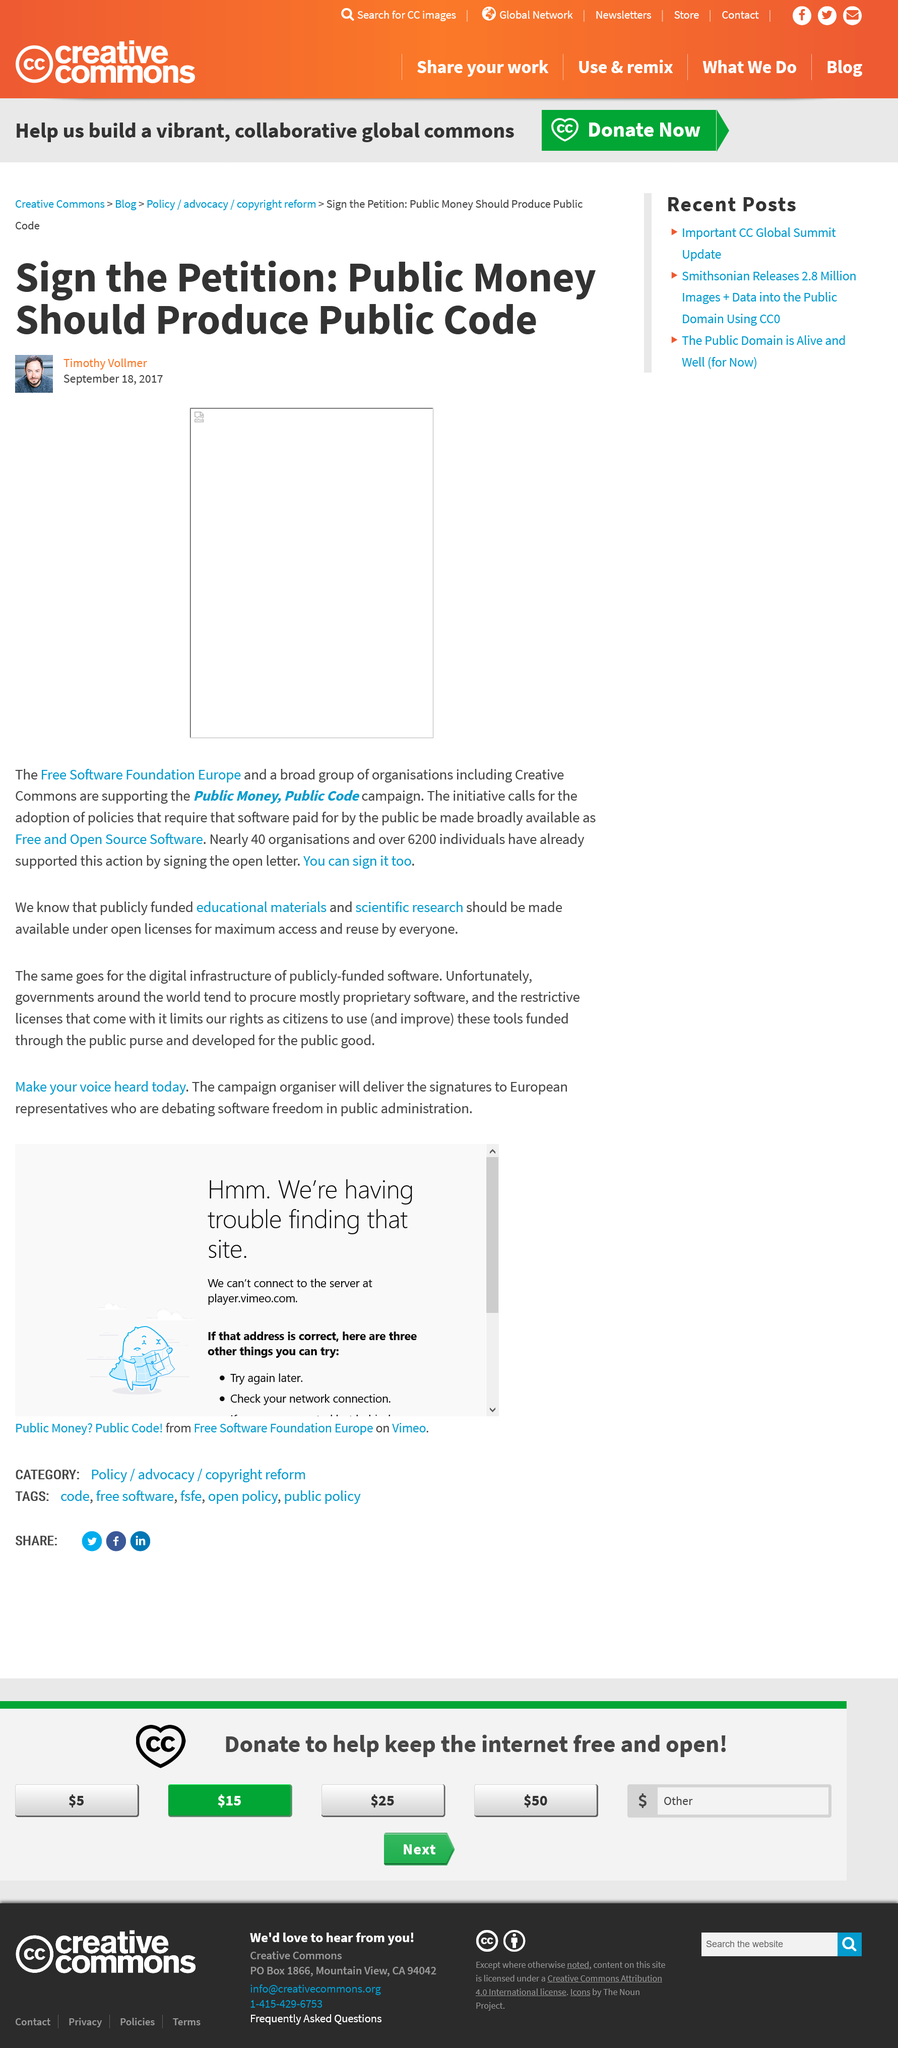Mention a couple of crucial points in this snapshot. The article is advocating for public money to produce public code. 40 organisations have supported the use of public money and code by signing a petition in support of this action. To date, a total of 6,200 individuals have publicly supported the use of public money and public code through a petition. 